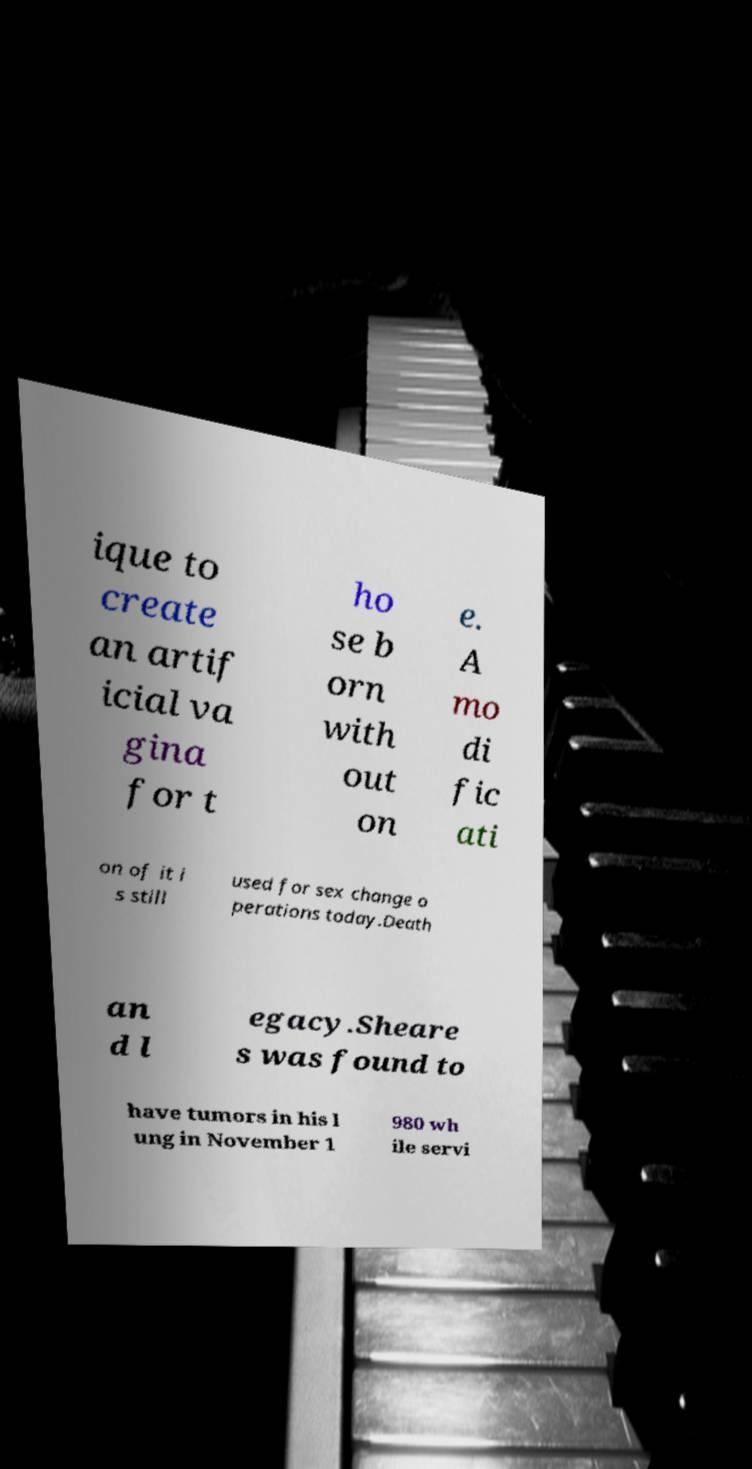I need the written content from this picture converted into text. Can you do that? ique to create an artif icial va gina for t ho se b orn with out on e. A mo di fic ati on of it i s still used for sex change o perations today.Death an d l egacy.Sheare s was found to have tumors in his l ung in November 1 980 wh ile servi 